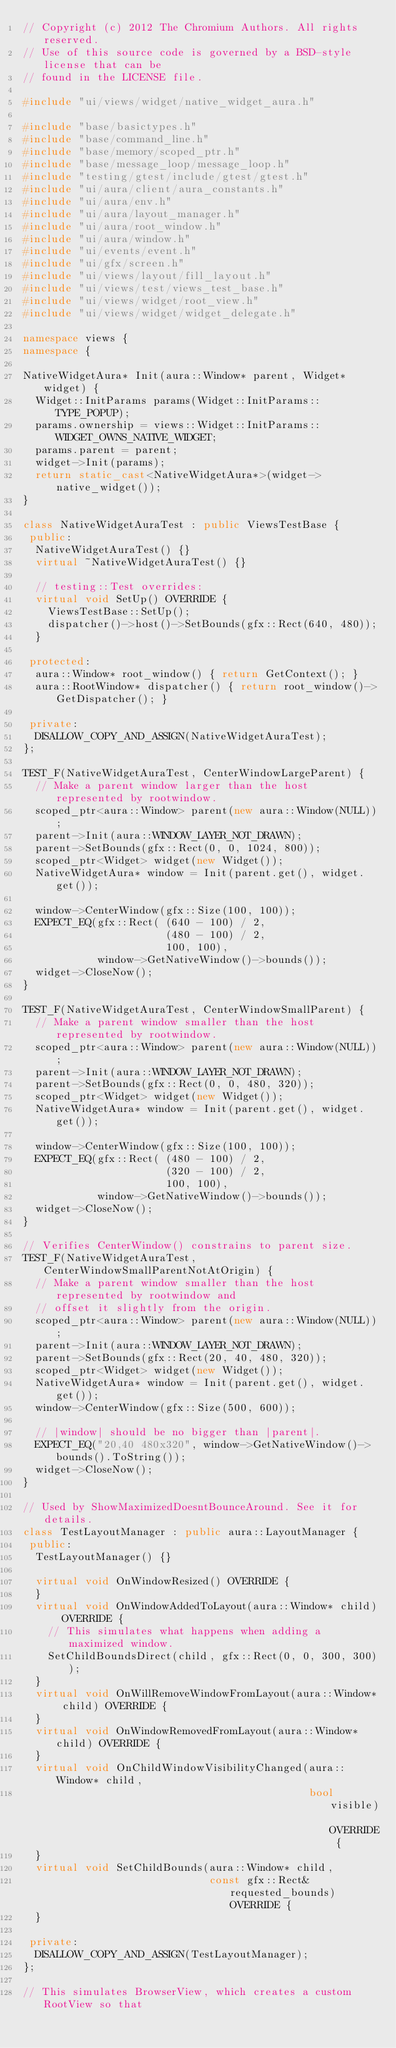Convert code to text. <code><loc_0><loc_0><loc_500><loc_500><_C++_>// Copyright (c) 2012 The Chromium Authors. All rights reserved.
// Use of this source code is governed by a BSD-style license that can be
// found in the LICENSE file.

#include "ui/views/widget/native_widget_aura.h"

#include "base/basictypes.h"
#include "base/command_line.h"
#include "base/memory/scoped_ptr.h"
#include "base/message_loop/message_loop.h"
#include "testing/gtest/include/gtest/gtest.h"
#include "ui/aura/client/aura_constants.h"
#include "ui/aura/env.h"
#include "ui/aura/layout_manager.h"
#include "ui/aura/root_window.h"
#include "ui/aura/window.h"
#include "ui/events/event.h"
#include "ui/gfx/screen.h"
#include "ui/views/layout/fill_layout.h"
#include "ui/views/test/views_test_base.h"
#include "ui/views/widget/root_view.h"
#include "ui/views/widget/widget_delegate.h"

namespace views {
namespace {

NativeWidgetAura* Init(aura::Window* parent, Widget* widget) {
  Widget::InitParams params(Widget::InitParams::TYPE_POPUP);
  params.ownership = views::Widget::InitParams::WIDGET_OWNS_NATIVE_WIDGET;
  params.parent = parent;
  widget->Init(params);
  return static_cast<NativeWidgetAura*>(widget->native_widget());
}

class NativeWidgetAuraTest : public ViewsTestBase {
 public:
  NativeWidgetAuraTest() {}
  virtual ~NativeWidgetAuraTest() {}

  // testing::Test overrides:
  virtual void SetUp() OVERRIDE {
    ViewsTestBase::SetUp();
    dispatcher()->host()->SetBounds(gfx::Rect(640, 480));
  }

 protected:
  aura::Window* root_window() { return GetContext(); }
  aura::RootWindow* dispatcher() { return root_window()->GetDispatcher(); }

 private:
  DISALLOW_COPY_AND_ASSIGN(NativeWidgetAuraTest);
};

TEST_F(NativeWidgetAuraTest, CenterWindowLargeParent) {
  // Make a parent window larger than the host represented by rootwindow.
  scoped_ptr<aura::Window> parent(new aura::Window(NULL));
  parent->Init(aura::WINDOW_LAYER_NOT_DRAWN);
  parent->SetBounds(gfx::Rect(0, 0, 1024, 800));
  scoped_ptr<Widget> widget(new Widget());
  NativeWidgetAura* window = Init(parent.get(), widget.get());

  window->CenterWindow(gfx::Size(100, 100));
  EXPECT_EQ(gfx::Rect( (640 - 100) / 2,
                       (480 - 100) / 2,
                       100, 100),
            window->GetNativeWindow()->bounds());
  widget->CloseNow();
}

TEST_F(NativeWidgetAuraTest, CenterWindowSmallParent) {
  // Make a parent window smaller than the host represented by rootwindow.
  scoped_ptr<aura::Window> parent(new aura::Window(NULL));
  parent->Init(aura::WINDOW_LAYER_NOT_DRAWN);
  parent->SetBounds(gfx::Rect(0, 0, 480, 320));
  scoped_ptr<Widget> widget(new Widget());
  NativeWidgetAura* window = Init(parent.get(), widget.get());

  window->CenterWindow(gfx::Size(100, 100));
  EXPECT_EQ(gfx::Rect( (480 - 100) / 2,
                       (320 - 100) / 2,
                       100, 100),
            window->GetNativeWindow()->bounds());
  widget->CloseNow();
}

// Verifies CenterWindow() constrains to parent size.
TEST_F(NativeWidgetAuraTest, CenterWindowSmallParentNotAtOrigin) {
  // Make a parent window smaller than the host represented by rootwindow and
  // offset it slightly from the origin.
  scoped_ptr<aura::Window> parent(new aura::Window(NULL));
  parent->Init(aura::WINDOW_LAYER_NOT_DRAWN);
  parent->SetBounds(gfx::Rect(20, 40, 480, 320));
  scoped_ptr<Widget> widget(new Widget());
  NativeWidgetAura* window = Init(parent.get(), widget.get());
  window->CenterWindow(gfx::Size(500, 600));

  // |window| should be no bigger than |parent|.
  EXPECT_EQ("20,40 480x320", window->GetNativeWindow()->bounds().ToString());
  widget->CloseNow();
}

// Used by ShowMaximizedDoesntBounceAround. See it for details.
class TestLayoutManager : public aura::LayoutManager {
 public:
  TestLayoutManager() {}

  virtual void OnWindowResized() OVERRIDE {
  }
  virtual void OnWindowAddedToLayout(aura::Window* child) OVERRIDE {
    // This simulates what happens when adding a maximized window.
    SetChildBoundsDirect(child, gfx::Rect(0, 0, 300, 300));
  }
  virtual void OnWillRemoveWindowFromLayout(aura::Window* child) OVERRIDE {
  }
  virtual void OnWindowRemovedFromLayout(aura::Window* child) OVERRIDE {
  }
  virtual void OnChildWindowVisibilityChanged(aura::Window* child,
                                              bool visible) OVERRIDE {
  }
  virtual void SetChildBounds(aura::Window* child,
                              const gfx::Rect& requested_bounds) OVERRIDE {
  }

 private:
  DISALLOW_COPY_AND_ASSIGN(TestLayoutManager);
};

// This simulates BrowserView, which creates a custom RootView so that</code> 